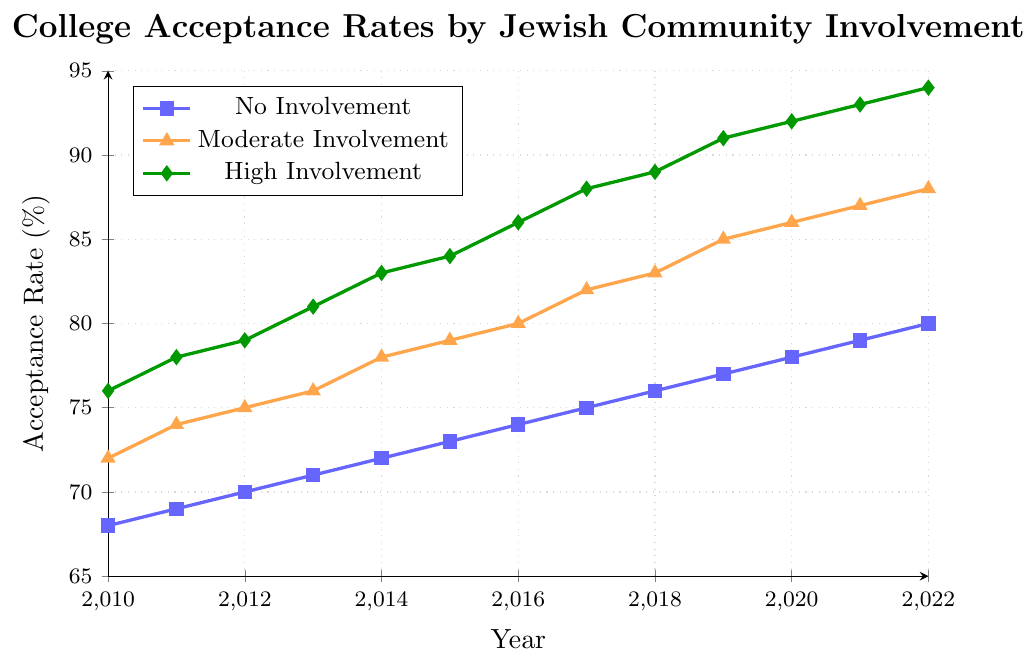What is the difference in acceptance rates between students with no involvement and high involvement in 2010? First, note the acceptance rate for no involvement in 2010, which is 68%. Then, note the acceptance rate for high involvement in 2010, which is 76%. Calculate the difference: 76% - 68% = 8%.
Answer: 8% How did the college acceptance rate for students with moderate involvement change from 2012 to 2016? Locate the acceptance rate for moderate involvement in 2012, which is 75%. Then, find the rate in 2016, which is 80%. Calculate the change: 80% - 75% = 5%.
Answer: 5% Which year saw the greatest increase in acceptance rates for students with no involvement, comparing year-over-year increases? Calculate the year-over-year differences for each year for no involvement. The differences are: 1% (2010 to 2011), 1% (2011 to 2012), 1% (2012 to 2013), 1% (2013 to 2014), 1% (2014 to 2015), 1% (2015 to 2016), 1% (2016 to 2017), 1% (2017 to 2018), 1% (2018 to 2019), 1% (2019 to 2020), 1% (2020 to 2021), 1% (2021 to 2022). Since all are equal increases, there is no year with a greater increase.
Answer: None Compare the acceptance rates for students with high involvement and moderate involvement in 2022. Locate the acceptance rate for high involvement in 2022, which is 94%. Then, locate the rate for moderate involvement in 2022, which is 88%. Since 94% is greater than 88%, students with high involvement have higher acceptance rates.
Answer: High involvement What is the trend in college acceptance rates for students with high involvement from 2010 to 2022? Observe the line representing high involvement from 2010 to 2022. The acceptance rates go from 76% in 2010 to 94% in 2022, indicating a steady upward trend.
Answer: Upward trend What is the acceptance rate difference between students with no involvement and moderate involvement in 2015? Note the acceptance rate for no involvement in 2015, which is 73%. Then, note the acceptance rate for moderate involvement in 2015, which is 79%. Calculate the difference: 79% - 73% = 6%.
Answer: 6% By how much did the acceptance rate for no involvement students increase from 2011 to 2020? First, note the acceptance rate for no involvement students in 2011, which is 69%. Then, find the rate in 2020, which is 78%. Calculate the increase: 78% - 69% = 9%.
Answer: 9% What can be inferred about the relationship between extracurricular involvement in Jewish community activities and college acceptance rates? By observing the lines, it is evident that higher levels of involvement are consistently associated with higher acceptance rates. High involvement shows the highest rates, followed by moderate and then no involvement. This indicates a positive correlation between the level of involvement and acceptance rates.
Answer: Positive correlation Which group showed the highest acceptance rate in 2013 and what was it? Find the acceptance rates for all groups in 2013. No involvement: 71%, moderate involvement: 76%, high involvement: 81%. The highest acceptance rate is for high involvement at 81%.
Answer: High involvement, 81% What is the average acceptance rate for students with no involvement from 2010 to 2022? List the rates: 68, 69, 70, 71, 72, 73, 74, 75, 76, 77, 78, 79, 80. Add these values: 68 + 69 + 70 + 71 + 72 + 73 + 74 + 75 + 76 + 77 + 78 + 79 + 80 = 983. Divide by the number of years (13): 983 / 13 ≈ 75.62%.
Answer: 75.62% 